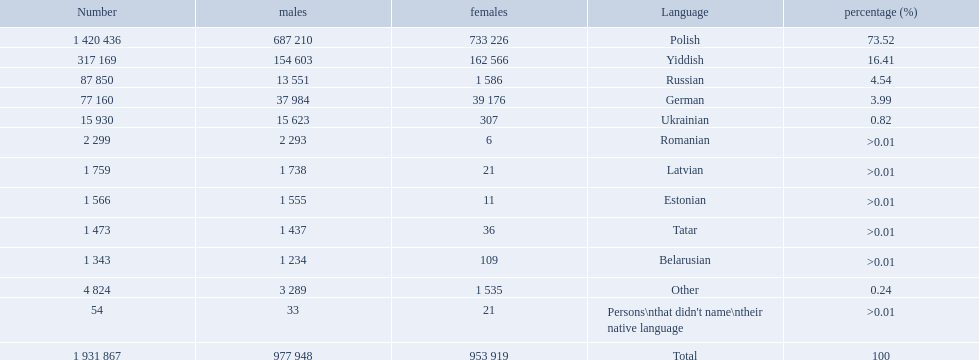What languages are spoken in the warsaw governorate? Polish, Yiddish, Russian, German, Ukrainian, Romanian, Latvian, Estonian, Tatar, Belarusian, Other, Persons\nthat didn't name\ntheir native language. What is the number for russian? 87 850. On this list what is the next lowest number? 77 160. Which language has a number of 77160 speakers? German. What are all the languages? Polish, Yiddish, Russian, German, Ukrainian, Romanian, Latvian, Estonian, Tatar, Belarusian, Other. Which only have percentages >0.01? Romanian, Latvian, Estonian, Tatar, Belarusian. Of these, which has the greatest number of speakers? Romanian. How many languages are there? Polish, Yiddish, Russian, German, Ukrainian, Romanian, Latvian, Estonian, Tatar, Belarusian. Which language do more people speak? Polish. 